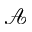Convert formula to latex. <formula><loc_0><loc_0><loc_500><loc_500>\mathcal { A }</formula> 